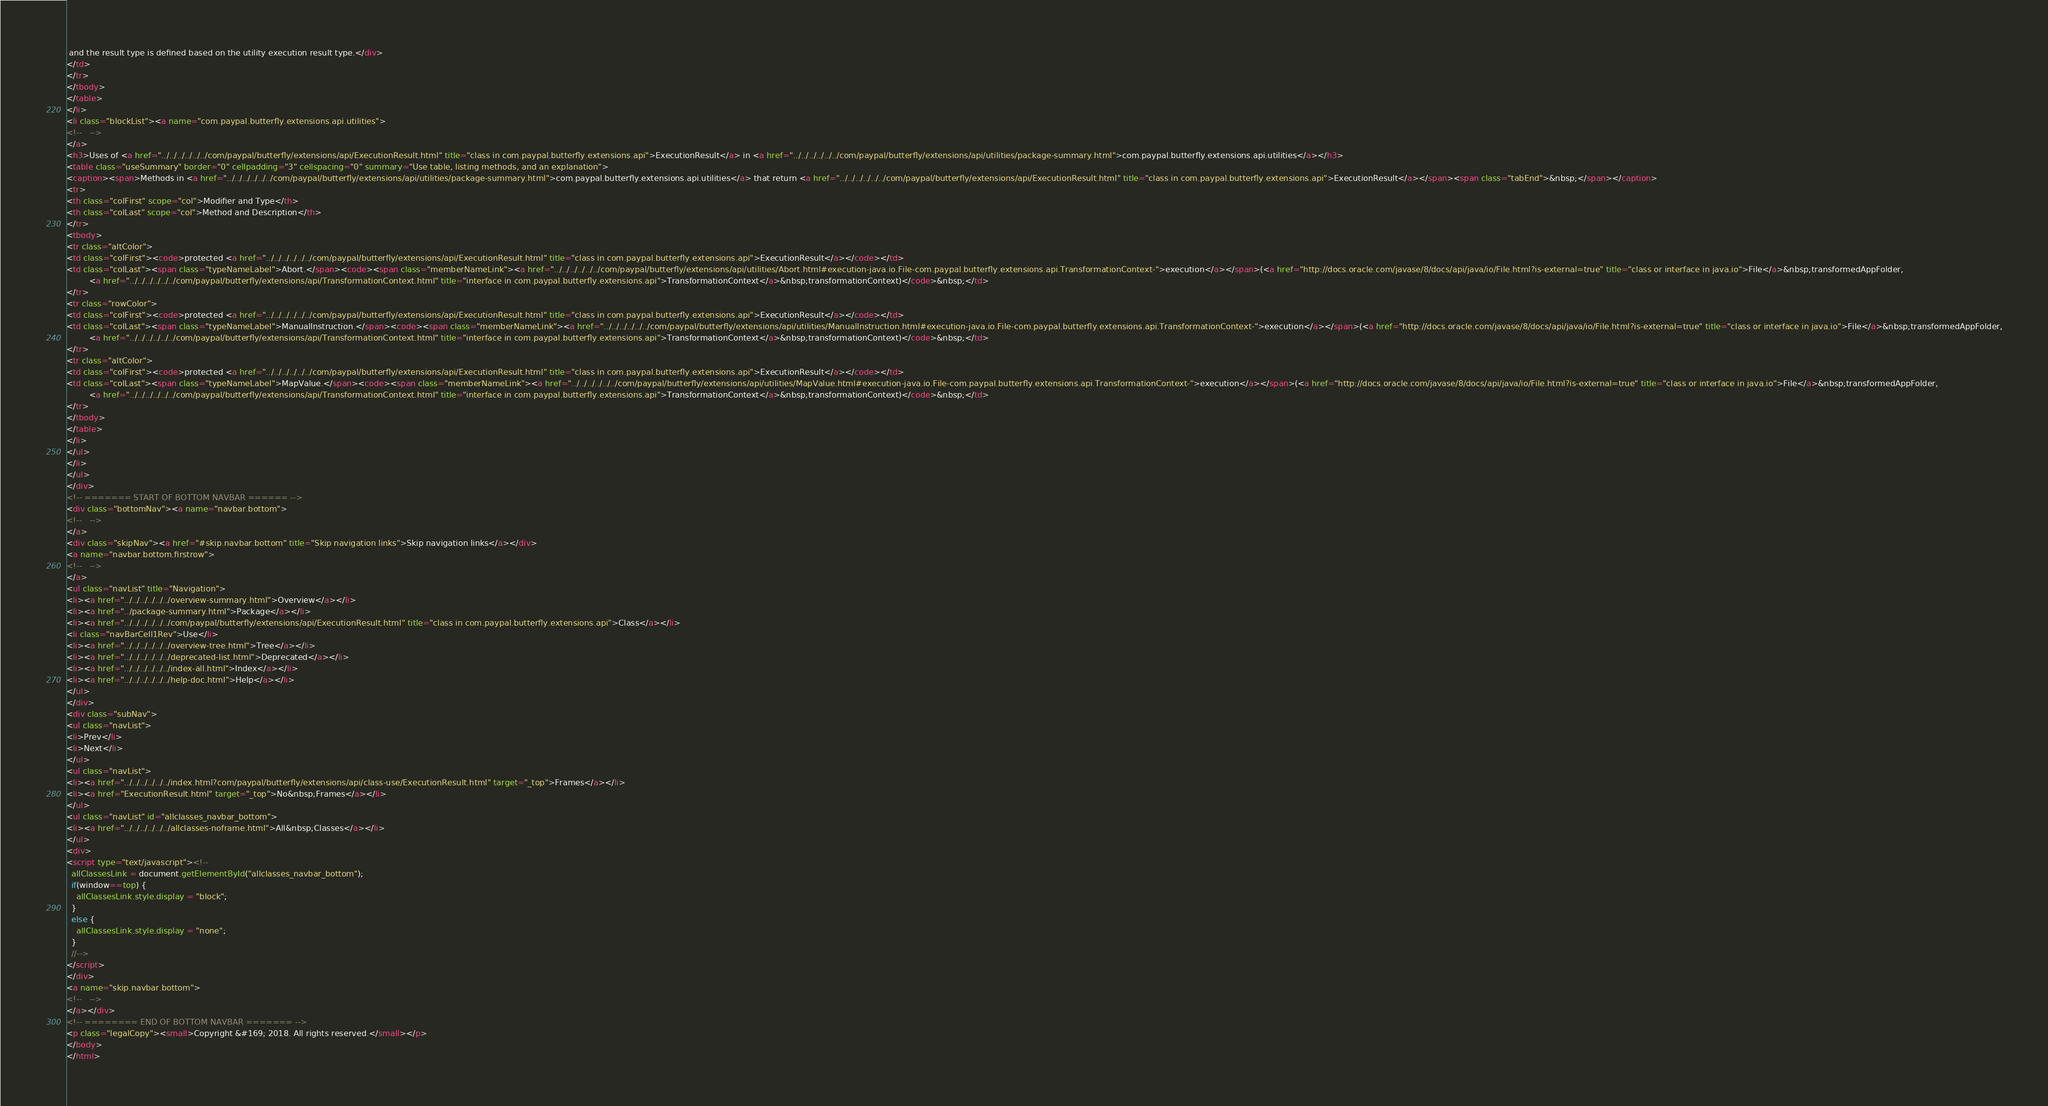Convert code to text. <code><loc_0><loc_0><loc_500><loc_500><_HTML_> and the result type is defined based on the utility execution result type.</div>
</td>
</tr>
</tbody>
</table>
</li>
<li class="blockList"><a name="com.paypal.butterfly.extensions.api.utilities">
<!--   -->
</a>
<h3>Uses of <a href="../../../../../../com/paypal/butterfly/extensions/api/ExecutionResult.html" title="class in com.paypal.butterfly.extensions.api">ExecutionResult</a> in <a href="../../../../../../com/paypal/butterfly/extensions/api/utilities/package-summary.html">com.paypal.butterfly.extensions.api.utilities</a></h3>
<table class="useSummary" border="0" cellpadding="3" cellspacing="0" summary="Use table, listing methods, and an explanation">
<caption><span>Methods in <a href="../../../../../../com/paypal/butterfly/extensions/api/utilities/package-summary.html">com.paypal.butterfly.extensions.api.utilities</a> that return <a href="../../../../../../com/paypal/butterfly/extensions/api/ExecutionResult.html" title="class in com.paypal.butterfly.extensions.api">ExecutionResult</a></span><span class="tabEnd">&nbsp;</span></caption>
<tr>
<th class="colFirst" scope="col">Modifier and Type</th>
<th class="colLast" scope="col">Method and Description</th>
</tr>
<tbody>
<tr class="altColor">
<td class="colFirst"><code>protected <a href="../../../../../../com/paypal/butterfly/extensions/api/ExecutionResult.html" title="class in com.paypal.butterfly.extensions.api">ExecutionResult</a></code></td>
<td class="colLast"><span class="typeNameLabel">Abort.</span><code><span class="memberNameLink"><a href="../../../../../../com/paypal/butterfly/extensions/api/utilities/Abort.html#execution-java.io.File-com.paypal.butterfly.extensions.api.TransformationContext-">execution</a></span>(<a href="http://docs.oracle.com/javase/8/docs/api/java/io/File.html?is-external=true" title="class or interface in java.io">File</a>&nbsp;transformedAppFolder,
         <a href="../../../../../../com/paypal/butterfly/extensions/api/TransformationContext.html" title="interface in com.paypal.butterfly.extensions.api">TransformationContext</a>&nbsp;transformationContext)</code>&nbsp;</td>
</tr>
<tr class="rowColor">
<td class="colFirst"><code>protected <a href="../../../../../../com/paypal/butterfly/extensions/api/ExecutionResult.html" title="class in com.paypal.butterfly.extensions.api">ExecutionResult</a></code></td>
<td class="colLast"><span class="typeNameLabel">ManualInstruction.</span><code><span class="memberNameLink"><a href="../../../../../../com/paypal/butterfly/extensions/api/utilities/ManualInstruction.html#execution-java.io.File-com.paypal.butterfly.extensions.api.TransformationContext-">execution</a></span>(<a href="http://docs.oracle.com/javase/8/docs/api/java/io/File.html?is-external=true" title="class or interface in java.io">File</a>&nbsp;transformedAppFolder,
         <a href="../../../../../../com/paypal/butterfly/extensions/api/TransformationContext.html" title="interface in com.paypal.butterfly.extensions.api">TransformationContext</a>&nbsp;transformationContext)</code>&nbsp;</td>
</tr>
<tr class="altColor">
<td class="colFirst"><code>protected <a href="../../../../../../com/paypal/butterfly/extensions/api/ExecutionResult.html" title="class in com.paypal.butterfly.extensions.api">ExecutionResult</a></code></td>
<td class="colLast"><span class="typeNameLabel">MapValue.</span><code><span class="memberNameLink"><a href="../../../../../../com/paypal/butterfly/extensions/api/utilities/MapValue.html#execution-java.io.File-com.paypal.butterfly.extensions.api.TransformationContext-">execution</a></span>(<a href="http://docs.oracle.com/javase/8/docs/api/java/io/File.html?is-external=true" title="class or interface in java.io">File</a>&nbsp;transformedAppFolder,
         <a href="../../../../../../com/paypal/butterfly/extensions/api/TransformationContext.html" title="interface in com.paypal.butterfly.extensions.api">TransformationContext</a>&nbsp;transformationContext)</code>&nbsp;</td>
</tr>
</tbody>
</table>
</li>
</ul>
</li>
</ul>
</div>
<!-- ======= START OF BOTTOM NAVBAR ====== -->
<div class="bottomNav"><a name="navbar.bottom">
<!--   -->
</a>
<div class="skipNav"><a href="#skip.navbar.bottom" title="Skip navigation links">Skip navigation links</a></div>
<a name="navbar.bottom.firstrow">
<!--   -->
</a>
<ul class="navList" title="Navigation">
<li><a href="../../../../../../overview-summary.html">Overview</a></li>
<li><a href="../package-summary.html">Package</a></li>
<li><a href="../../../../../../com/paypal/butterfly/extensions/api/ExecutionResult.html" title="class in com.paypal.butterfly.extensions.api">Class</a></li>
<li class="navBarCell1Rev">Use</li>
<li><a href="../../../../../../overview-tree.html">Tree</a></li>
<li><a href="../../../../../../deprecated-list.html">Deprecated</a></li>
<li><a href="../../../../../../index-all.html">Index</a></li>
<li><a href="../../../../../../help-doc.html">Help</a></li>
</ul>
</div>
<div class="subNav">
<ul class="navList">
<li>Prev</li>
<li>Next</li>
</ul>
<ul class="navList">
<li><a href="../../../../../../index.html?com/paypal/butterfly/extensions/api/class-use/ExecutionResult.html" target="_top">Frames</a></li>
<li><a href="ExecutionResult.html" target="_top">No&nbsp;Frames</a></li>
</ul>
<ul class="navList" id="allclasses_navbar_bottom">
<li><a href="../../../../../../allclasses-noframe.html">All&nbsp;Classes</a></li>
</ul>
<div>
<script type="text/javascript"><!--
  allClassesLink = document.getElementById("allclasses_navbar_bottom");
  if(window==top) {
    allClassesLink.style.display = "block";
  }
  else {
    allClassesLink.style.display = "none";
  }
  //-->
</script>
</div>
<a name="skip.navbar.bottom">
<!--   -->
</a></div>
<!-- ======== END OF BOTTOM NAVBAR ======= -->
<p class="legalCopy"><small>Copyright &#169; 2018. All rights reserved.</small></p>
</body>
</html>
</code> 